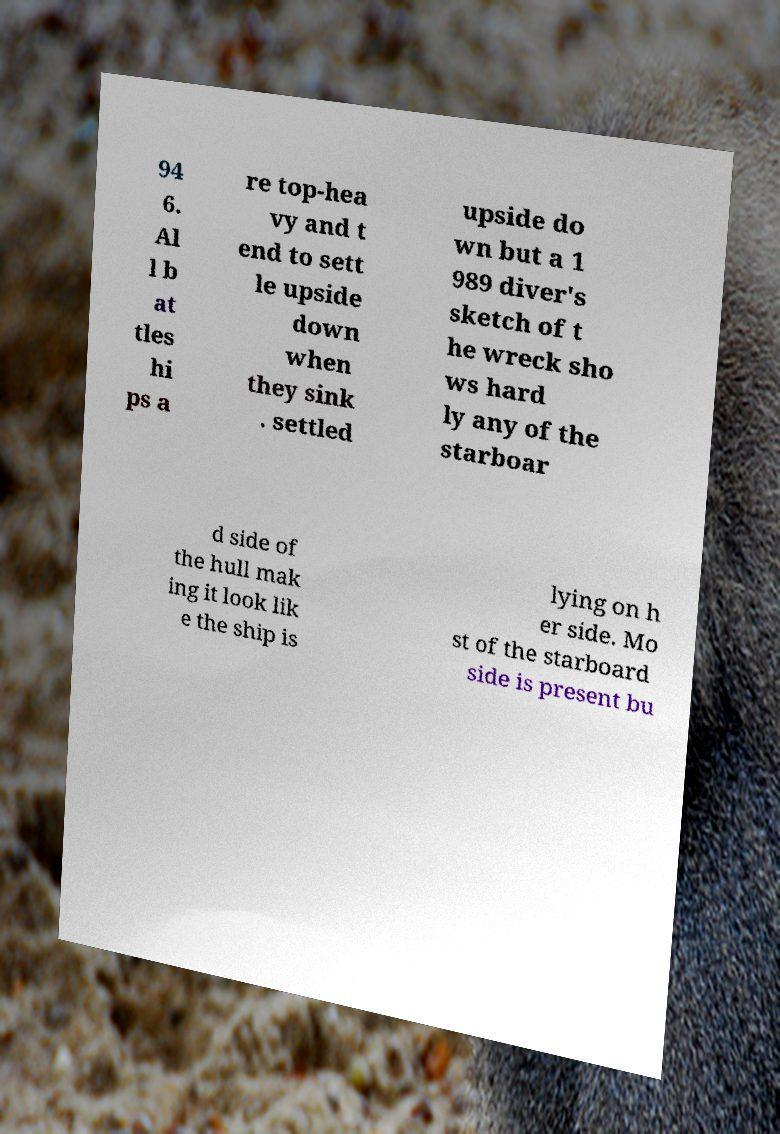Can you read and provide the text displayed in the image?This photo seems to have some interesting text. Can you extract and type it out for me? 94 6. Al l b at tles hi ps a re top-hea vy and t end to sett le upside down when they sink . settled upside do wn but a 1 989 diver's sketch of t he wreck sho ws hard ly any of the starboar d side of the hull mak ing it look lik e the ship is lying on h er side. Mo st of the starboard side is present bu 